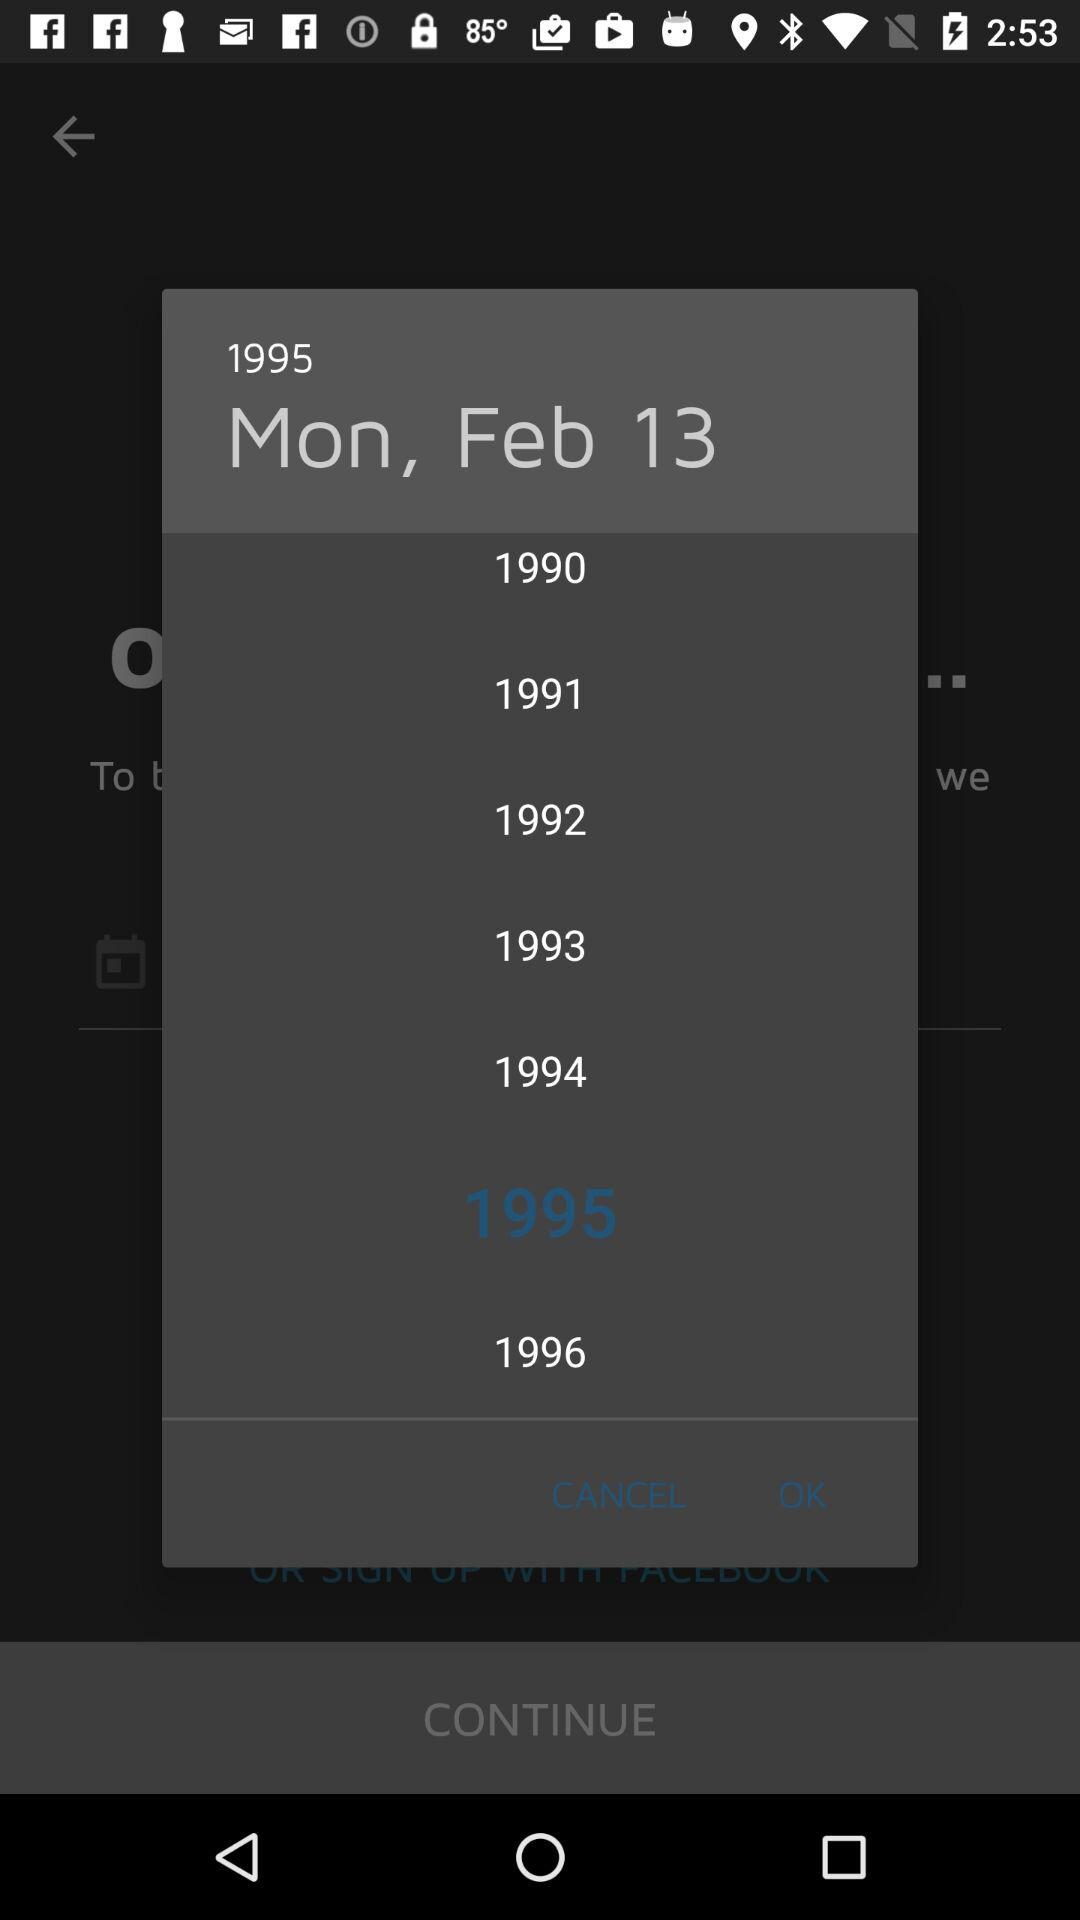What day is it on February 13? The day is Monday. 